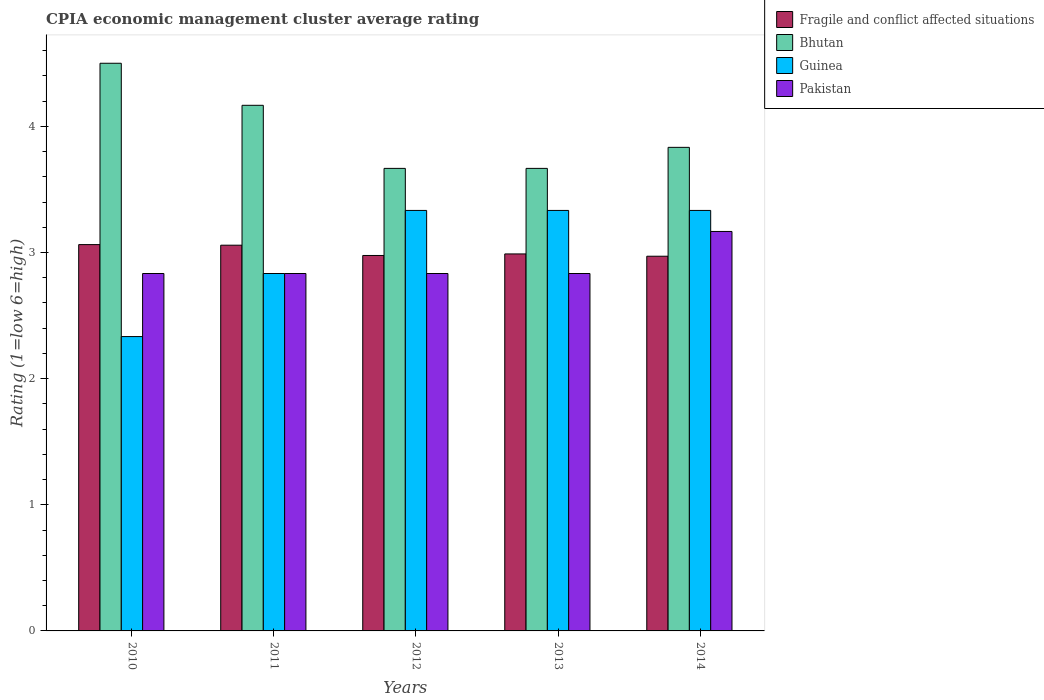How many different coloured bars are there?
Offer a terse response. 4. Are the number of bars per tick equal to the number of legend labels?
Offer a terse response. Yes. What is the CPIA rating in Guinea in 2012?
Your answer should be very brief. 3.33. Across all years, what is the maximum CPIA rating in Bhutan?
Your response must be concise. 4.5. Across all years, what is the minimum CPIA rating in Fragile and conflict affected situations?
Your response must be concise. 2.97. In which year was the CPIA rating in Guinea maximum?
Offer a terse response. 2012. In which year was the CPIA rating in Bhutan minimum?
Offer a very short reply. 2012. What is the total CPIA rating in Guinea in the graph?
Provide a succinct answer. 15.17. What is the difference between the CPIA rating in Fragile and conflict affected situations in 2011 and the CPIA rating in Bhutan in 2014?
Your response must be concise. -0.78. What is the average CPIA rating in Bhutan per year?
Provide a succinct answer. 3.97. In the year 2012, what is the difference between the CPIA rating in Bhutan and CPIA rating in Guinea?
Ensure brevity in your answer.  0.33. In how many years, is the CPIA rating in Pakistan greater than 2.6?
Give a very brief answer. 5. What is the ratio of the CPIA rating in Fragile and conflict affected situations in 2011 to that in 2013?
Your answer should be very brief. 1.02. What is the difference between the highest and the second highest CPIA rating in Bhutan?
Make the answer very short. 0.33. What is the difference between the highest and the lowest CPIA rating in Pakistan?
Your answer should be compact. 0.33. Is the sum of the CPIA rating in Bhutan in 2010 and 2011 greater than the maximum CPIA rating in Pakistan across all years?
Provide a short and direct response. Yes. What does the 3rd bar from the right in 2013 represents?
Keep it short and to the point. Bhutan. Is it the case that in every year, the sum of the CPIA rating in Fragile and conflict affected situations and CPIA rating in Pakistan is greater than the CPIA rating in Bhutan?
Provide a succinct answer. Yes. Does the graph contain any zero values?
Your answer should be compact. No. Where does the legend appear in the graph?
Keep it short and to the point. Top right. What is the title of the graph?
Offer a terse response. CPIA economic management cluster average rating. Does "Somalia" appear as one of the legend labels in the graph?
Keep it short and to the point. No. What is the label or title of the X-axis?
Provide a succinct answer. Years. What is the Rating (1=low 6=high) of Fragile and conflict affected situations in 2010?
Offer a very short reply. 3.06. What is the Rating (1=low 6=high) in Bhutan in 2010?
Offer a terse response. 4.5. What is the Rating (1=low 6=high) of Guinea in 2010?
Your answer should be very brief. 2.33. What is the Rating (1=low 6=high) in Pakistan in 2010?
Your response must be concise. 2.83. What is the Rating (1=low 6=high) in Fragile and conflict affected situations in 2011?
Ensure brevity in your answer.  3.06. What is the Rating (1=low 6=high) in Bhutan in 2011?
Offer a terse response. 4.17. What is the Rating (1=low 6=high) of Guinea in 2011?
Provide a succinct answer. 2.83. What is the Rating (1=low 6=high) of Pakistan in 2011?
Your response must be concise. 2.83. What is the Rating (1=low 6=high) of Fragile and conflict affected situations in 2012?
Ensure brevity in your answer.  2.98. What is the Rating (1=low 6=high) of Bhutan in 2012?
Keep it short and to the point. 3.67. What is the Rating (1=low 6=high) of Guinea in 2012?
Offer a very short reply. 3.33. What is the Rating (1=low 6=high) in Pakistan in 2012?
Offer a terse response. 2.83. What is the Rating (1=low 6=high) in Fragile and conflict affected situations in 2013?
Give a very brief answer. 2.99. What is the Rating (1=low 6=high) in Bhutan in 2013?
Ensure brevity in your answer.  3.67. What is the Rating (1=low 6=high) in Guinea in 2013?
Offer a terse response. 3.33. What is the Rating (1=low 6=high) in Pakistan in 2013?
Make the answer very short. 2.83. What is the Rating (1=low 6=high) of Fragile and conflict affected situations in 2014?
Your answer should be very brief. 2.97. What is the Rating (1=low 6=high) in Bhutan in 2014?
Give a very brief answer. 3.83. What is the Rating (1=low 6=high) of Guinea in 2014?
Provide a short and direct response. 3.33. What is the Rating (1=low 6=high) in Pakistan in 2014?
Provide a succinct answer. 3.17. Across all years, what is the maximum Rating (1=low 6=high) of Fragile and conflict affected situations?
Provide a short and direct response. 3.06. Across all years, what is the maximum Rating (1=low 6=high) in Guinea?
Ensure brevity in your answer.  3.33. Across all years, what is the maximum Rating (1=low 6=high) of Pakistan?
Make the answer very short. 3.17. Across all years, what is the minimum Rating (1=low 6=high) of Fragile and conflict affected situations?
Keep it short and to the point. 2.97. Across all years, what is the minimum Rating (1=low 6=high) in Bhutan?
Offer a terse response. 3.67. Across all years, what is the minimum Rating (1=low 6=high) in Guinea?
Your answer should be very brief. 2.33. Across all years, what is the minimum Rating (1=low 6=high) of Pakistan?
Ensure brevity in your answer.  2.83. What is the total Rating (1=low 6=high) in Fragile and conflict affected situations in the graph?
Keep it short and to the point. 15.06. What is the total Rating (1=low 6=high) of Bhutan in the graph?
Your answer should be compact. 19.83. What is the total Rating (1=low 6=high) of Guinea in the graph?
Give a very brief answer. 15.17. What is the total Rating (1=low 6=high) in Pakistan in the graph?
Your answer should be compact. 14.5. What is the difference between the Rating (1=low 6=high) in Fragile and conflict affected situations in 2010 and that in 2011?
Make the answer very short. 0. What is the difference between the Rating (1=low 6=high) of Bhutan in 2010 and that in 2011?
Offer a very short reply. 0.33. What is the difference between the Rating (1=low 6=high) of Pakistan in 2010 and that in 2011?
Offer a very short reply. 0. What is the difference between the Rating (1=low 6=high) in Fragile and conflict affected situations in 2010 and that in 2012?
Offer a terse response. 0.09. What is the difference between the Rating (1=low 6=high) in Guinea in 2010 and that in 2012?
Provide a short and direct response. -1. What is the difference between the Rating (1=low 6=high) in Fragile and conflict affected situations in 2010 and that in 2013?
Your response must be concise. 0.07. What is the difference between the Rating (1=low 6=high) of Guinea in 2010 and that in 2013?
Your answer should be compact. -1. What is the difference between the Rating (1=low 6=high) of Fragile and conflict affected situations in 2010 and that in 2014?
Offer a terse response. 0.09. What is the difference between the Rating (1=low 6=high) in Pakistan in 2010 and that in 2014?
Make the answer very short. -0.33. What is the difference between the Rating (1=low 6=high) of Fragile and conflict affected situations in 2011 and that in 2012?
Make the answer very short. 0.08. What is the difference between the Rating (1=low 6=high) of Bhutan in 2011 and that in 2012?
Keep it short and to the point. 0.5. What is the difference between the Rating (1=low 6=high) in Guinea in 2011 and that in 2012?
Your answer should be compact. -0.5. What is the difference between the Rating (1=low 6=high) of Fragile and conflict affected situations in 2011 and that in 2013?
Keep it short and to the point. 0.07. What is the difference between the Rating (1=low 6=high) in Guinea in 2011 and that in 2013?
Give a very brief answer. -0.5. What is the difference between the Rating (1=low 6=high) in Fragile and conflict affected situations in 2011 and that in 2014?
Your response must be concise. 0.09. What is the difference between the Rating (1=low 6=high) in Guinea in 2011 and that in 2014?
Ensure brevity in your answer.  -0.5. What is the difference between the Rating (1=low 6=high) in Pakistan in 2011 and that in 2014?
Your answer should be compact. -0.33. What is the difference between the Rating (1=low 6=high) of Fragile and conflict affected situations in 2012 and that in 2013?
Give a very brief answer. -0.01. What is the difference between the Rating (1=low 6=high) in Bhutan in 2012 and that in 2013?
Give a very brief answer. 0. What is the difference between the Rating (1=low 6=high) in Fragile and conflict affected situations in 2012 and that in 2014?
Offer a very short reply. 0.01. What is the difference between the Rating (1=low 6=high) in Bhutan in 2012 and that in 2014?
Your answer should be compact. -0.17. What is the difference between the Rating (1=low 6=high) in Guinea in 2012 and that in 2014?
Make the answer very short. 0. What is the difference between the Rating (1=low 6=high) of Pakistan in 2012 and that in 2014?
Your response must be concise. -0.33. What is the difference between the Rating (1=low 6=high) in Fragile and conflict affected situations in 2013 and that in 2014?
Ensure brevity in your answer.  0.02. What is the difference between the Rating (1=low 6=high) in Guinea in 2013 and that in 2014?
Give a very brief answer. 0. What is the difference between the Rating (1=low 6=high) in Pakistan in 2013 and that in 2014?
Your answer should be very brief. -0.33. What is the difference between the Rating (1=low 6=high) in Fragile and conflict affected situations in 2010 and the Rating (1=low 6=high) in Bhutan in 2011?
Offer a very short reply. -1.1. What is the difference between the Rating (1=low 6=high) in Fragile and conflict affected situations in 2010 and the Rating (1=low 6=high) in Guinea in 2011?
Provide a succinct answer. 0.23. What is the difference between the Rating (1=low 6=high) in Fragile and conflict affected situations in 2010 and the Rating (1=low 6=high) in Pakistan in 2011?
Offer a terse response. 0.23. What is the difference between the Rating (1=low 6=high) in Bhutan in 2010 and the Rating (1=low 6=high) in Guinea in 2011?
Offer a very short reply. 1.67. What is the difference between the Rating (1=low 6=high) of Guinea in 2010 and the Rating (1=low 6=high) of Pakistan in 2011?
Keep it short and to the point. -0.5. What is the difference between the Rating (1=low 6=high) of Fragile and conflict affected situations in 2010 and the Rating (1=low 6=high) of Bhutan in 2012?
Ensure brevity in your answer.  -0.6. What is the difference between the Rating (1=low 6=high) of Fragile and conflict affected situations in 2010 and the Rating (1=low 6=high) of Guinea in 2012?
Ensure brevity in your answer.  -0.27. What is the difference between the Rating (1=low 6=high) in Fragile and conflict affected situations in 2010 and the Rating (1=low 6=high) in Pakistan in 2012?
Your answer should be very brief. 0.23. What is the difference between the Rating (1=low 6=high) in Fragile and conflict affected situations in 2010 and the Rating (1=low 6=high) in Bhutan in 2013?
Ensure brevity in your answer.  -0.6. What is the difference between the Rating (1=low 6=high) in Fragile and conflict affected situations in 2010 and the Rating (1=low 6=high) in Guinea in 2013?
Provide a succinct answer. -0.27. What is the difference between the Rating (1=low 6=high) in Fragile and conflict affected situations in 2010 and the Rating (1=low 6=high) in Pakistan in 2013?
Make the answer very short. 0.23. What is the difference between the Rating (1=low 6=high) of Bhutan in 2010 and the Rating (1=low 6=high) of Guinea in 2013?
Your response must be concise. 1.17. What is the difference between the Rating (1=low 6=high) in Bhutan in 2010 and the Rating (1=low 6=high) in Pakistan in 2013?
Give a very brief answer. 1.67. What is the difference between the Rating (1=low 6=high) in Guinea in 2010 and the Rating (1=low 6=high) in Pakistan in 2013?
Make the answer very short. -0.5. What is the difference between the Rating (1=low 6=high) in Fragile and conflict affected situations in 2010 and the Rating (1=low 6=high) in Bhutan in 2014?
Offer a terse response. -0.77. What is the difference between the Rating (1=low 6=high) in Fragile and conflict affected situations in 2010 and the Rating (1=low 6=high) in Guinea in 2014?
Provide a succinct answer. -0.27. What is the difference between the Rating (1=low 6=high) of Fragile and conflict affected situations in 2010 and the Rating (1=low 6=high) of Pakistan in 2014?
Ensure brevity in your answer.  -0.1. What is the difference between the Rating (1=low 6=high) in Bhutan in 2010 and the Rating (1=low 6=high) in Guinea in 2014?
Keep it short and to the point. 1.17. What is the difference between the Rating (1=low 6=high) of Bhutan in 2010 and the Rating (1=low 6=high) of Pakistan in 2014?
Provide a short and direct response. 1.33. What is the difference between the Rating (1=low 6=high) in Guinea in 2010 and the Rating (1=low 6=high) in Pakistan in 2014?
Offer a terse response. -0.83. What is the difference between the Rating (1=low 6=high) of Fragile and conflict affected situations in 2011 and the Rating (1=low 6=high) of Bhutan in 2012?
Make the answer very short. -0.61. What is the difference between the Rating (1=low 6=high) in Fragile and conflict affected situations in 2011 and the Rating (1=low 6=high) in Guinea in 2012?
Keep it short and to the point. -0.28. What is the difference between the Rating (1=low 6=high) of Fragile and conflict affected situations in 2011 and the Rating (1=low 6=high) of Pakistan in 2012?
Your answer should be compact. 0.22. What is the difference between the Rating (1=low 6=high) of Bhutan in 2011 and the Rating (1=low 6=high) of Guinea in 2012?
Your answer should be very brief. 0.83. What is the difference between the Rating (1=low 6=high) in Bhutan in 2011 and the Rating (1=low 6=high) in Pakistan in 2012?
Ensure brevity in your answer.  1.33. What is the difference between the Rating (1=low 6=high) in Guinea in 2011 and the Rating (1=low 6=high) in Pakistan in 2012?
Offer a very short reply. 0. What is the difference between the Rating (1=low 6=high) of Fragile and conflict affected situations in 2011 and the Rating (1=low 6=high) of Bhutan in 2013?
Offer a very short reply. -0.61. What is the difference between the Rating (1=low 6=high) in Fragile and conflict affected situations in 2011 and the Rating (1=low 6=high) in Guinea in 2013?
Make the answer very short. -0.28. What is the difference between the Rating (1=low 6=high) in Fragile and conflict affected situations in 2011 and the Rating (1=low 6=high) in Pakistan in 2013?
Your answer should be compact. 0.22. What is the difference between the Rating (1=low 6=high) of Bhutan in 2011 and the Rating (1=low 6=high) of Guinea in 2013?
Ensure brevity in your answer.  0.83. What is the difference between the Rating (1=low 6=high) of Fragile and conflict affected situations in 2011 and the Rating (1=low 6=high) of Bhutan in 2014?
Ensure brevity in your answer.  -0.78. What is the difference between the Rating (1=low 6=high) in Fragile and conflict affected situations in 2011 and the Rating (1=low 6=high) in Guinea in 2014?
Provide a short and direct response. -0.28. What is the difference between the Rating (1=low 6=high) in Fragile and conflict affected situations in 2011 and the Rating (1=low 6=high) in Pakistan in 2014?
Give a very brief answer. -0.11. What is the difference between the Rating (1=low 6=high) in Bhutan in 2011 and the Rating (1=low 6=high) in Guinea in 2014?
Give a very brief answer. 0.83. What is the difference between the Rating (1=low 6=high) in Fragile and conflict affected situations in 2012 and the Rating (1=low 6=high) in Bhutan in 2013?
Make the answer very short. -0.69. What is the difference between the Rating (1=low 6=high) of Fragile and conflict affected situations in 2012 and the Rating (1=low 6=high) of Guinea in 2013?
Offer a terse response. -0.36. What is the difference between the Rating (1=low 6=high) in Fragile and conflict affected situations in 2012 and the Rating (1=low 6=high) in Pakistan in 2013?
Your answer should be very brief. 0.14. What is the difference between the Rating (1=low 6=high) in Bhutan in 2012 and the Rating (1=low 6=high) in Pakistan in 2013?
Your response must be concise. 0.83. What is the difference between the Rating (1=low 6=high) in Fragile and conflict affected situations in 2012 and the Rating (1=low 6=high) in Bhutan in 2014?
Offer a terse response. -0.86. What is the difference between the Rating (1=low 6=high) of Fragile and conflict affected situations in 2012 and the Rating (1=low 6=high) of Guinea in 2014?
Your answer should be compact. -0.36. What is the difference between the Rating (1=low 6=high) of Fragile and conflict affected situations in 2012 and the Rating (1=low 6=high) of Pakistan in 2014?
Make the answer very short. -0.19. What is the difference between the Rating (1=low 6=high) in Bhutan in 2012 and the Rating (1=low 6=high) in Guinea in 2014?
Offer a terse response. 0.33. What is the difference between the Rating (1=low 6=high) of Guinea in 2012 and the Rating (1=low 6=high) of Pakistan in 2014?
Keep it short and to the point. 0.17. What is the difference between the Rating (1=low 6=high) of Fragile and conflict affected situations in 2013 and the Rating (1=low 6=high) of Bhutan in 2014?
Your answer should be very brief. -0.84. What is the difference between the Rating (1=low 6=high) in Fragile and conflict affected situations in 2013 and the Rating (1=low 6=high) in Guinea in 2014?
Offer a terse response. -0.34. What is the difference between the Rating (1=low 6=high) of Fragile and conflict affected situations in 2013 and the Rating (1=low 6=high) of Pakistan in 2014?
Make the answer very short. -0.18. What is the difference between the Rating (1=low 6=high) of Bhutan in 2013 and the Rating (1=low 6=high) of Guinea in 2014?
Offer a terse response. 0.33. What is the difference between the Rating (1=low 6=high) in Guinea in 2013 and the Rating (1=low 6=high) in Pakistan in 2014?
Your response must be concise. 0.17. What is the average Rating (1=low 6=high) of Fragile and conflict affected situations per year?
Offer a very short reply. 3.01. What is the average Rating (1=low 6=high) in Bhutan per year?
Give a very brief answer. 3.97. What is the average Rating (1=low 6=high) in Guinea per year?
Your answer should be very brief. 3.03. What is the average Rating (1=low 6=high) in Pakistan per year?
Provide a succinct answer. 2.9. In the year 2010, what is the difference between the Rating (1=low 6=high) in Fragile and conflict affected situations and Rating (1=low 6=high) in Bhutan?
Offer a terse response. -1.44. In the year 2010, what is the difference between the Rating (1=low 6=high) in Fragile and conflict affected situations and Rating (1=low 6=high) in Guinea?
Offer a terse response. 0.73. In the year 2010, what is the difference between the Rating (1=low 6=high) in Fragile and conflict affected situations and Rating (1=low 6=high) in Pakistan?
Offer a terse response. 0.23. In the year 2010, what is the difference between the Rating (1=low 6=high) in Bhutan and Rating (1=low 6=high) in Guinea?
Provide a succinct answer. 2.17. In the year 2010, what is the difference between the Rating (1=low 6=high) of Guinea and Rating (1=low 6=high) of Pakistan?
Your response must be concise. -0.5. In the year 2011, what is the difference between the Rating (1=low 6=high) in Fragile and conflict affected situations and Rating (1=low 6=high) in Bhutan?
Your answer should be very brief. -1.11. In the year 2011, what is the difference between the Rating (1=low 6=high) of Fragile and conflict affected situations and Rating (1=low 6=high) of Guinea?
Provide a short and direct response. 0.22. In the year 2011, what is the difference between the Rating (1=low 6=high) in Fragile and conflict affected situations and Rating (1=low 6=high) in Pakistan?
Keep it short and to the point. 0.22. In the year 2011, what is the difference between the Rating (1=low 6=high) of Bhutan and Rating (1=low 6=high) of Pakistan?
Make the answer very short. 1.33. In the year 2012, what is the difference between the Rating (1=low 6=high) in Fragile and conflict affected situations and Rating (1=low 6=high) in Bhutan?
Make the answer very short. -0.69. In the year 2012, what is the difference between the Rating (1=low 6=high) of Fragile and conflict affected situations and Rating (1=low 6=high) of Guinea?
Your answer should be very brief. -0.36. In the year 2012, what is the difference between the Rating (1=low 6=high) in Fragile and conflict affected situations and Rating (1=low 6=high) in Pakistan?
Ensure brevity in your answer.  0.14. In the year 2012, what is the difference between the Rating (1=low 6=high) in Bhutan and Rating (1=low 6=high) in Guinea?
Ensure brevity in your answer.  0.33. In the year 2013, what is the difference between the Rating (1=low 6=high) of Fragile and conflict affected situations and Rating (1=low 6=high) of Bhutan?
Your answer should be very brief. -0.68. In the year 2013, what is the difference between the Rating (1=low 6=high) in Fragile and conflict affected situations and Rating (1=low 6=high) in Guinea?
Provide a short and direct response. -0.34. In the year 2013, what is the difference between the Rating (1=low 6=high) of Fragile and conflict affected situations and Rating (1=low 6=high) of Pakistan?
Your response must be concise. 0.16. In the year 2013, what is the difference between the Rating (1=low 6=high) in Guinea and Rating (1=low 6=high) in Pakistan?
Ensure brevity in your answer.  0.5. In the year 2014, what is the difference between the Rating (1=low 6=high) in Fragile and conflict affected situations and Rating (1=low 6=high) in Bhutan?
Provide a short and direct response. -0.86. In the year 2014, what is the difference between the Rating (1=low 6=high) of Fragile and conflict affected situations and Rating (1=low 6=high) of Guinea?
Offer a terse response. -0.36. In the year 2014, what is the difference between the Rating (1=low 6=high) of Fragile and conflict affected situations and Rating (1=low 6=high) of Pakistan?
Your answer should be very brief. -0.2. In the year 2014, what is the difference between the Rating (1=low 6=high) of Bhutan and Rating (1=low 6=high) of Guinea?
Your answer should be compact. 0.5. In the year 2014, what is the difference between the Rating (1=low 6=high) in Guinea and Rating (1=low 6=high) in Pakistan?
Your answer should be very brief. 0.17. What is the ratio of the Rating (1=low 6=high) in Bhutan in 2010 to that in 2011?
Offer a very short reply. 1.08. What is the ratio of the Rating (1=low 6=high) in Guinea in 2010 to that in 2011?
Keep it short and to the point. 0.82. What is the ratio of the Rating (1=low 6=high) of Pakistan in 2010 to that in 2011?
Your response must be concise. 1. What is the ratio of the Rating (1=low 6=high) of Bhutan in 2010 to that in 2012?
Keep it short and to the point. 1.23. What is the ratio of the Rating (1=low 6=high) of Guinea in 2010 to that in 2012?
Give a very brief answer. 0.7. What is the ratio of the Rating (1=low 6=high) in Pakistan in 2010 to that in 2012?
Give a very brief answer. 1. What is the ratio of the Rating (1=low 6=high) of Fragile and conflict affected situations in 2010 to that in 2013?
Your answer should be very brief. 1.02. What is the ratio of the Rating (1=low 6=high) in Bhutan in 2010 to that in 2013?
Provide a succinct answer. 1.23. What is the ratio of the Rating (1=low 6=high) of Guinea in 2010 to that in 2013?
Ensure brevity in your answer.  0.7. What is the ratio of the Rating (1=low 6=high) in Fragile and conflict affected situations in 2010 to that in 2014?
Give a very brief answer. 1.03. What is the ratio of the Rating (1=low 6=high) in Bhutan in 2010 to that in 2014?
Offer a terse response. 1.17. What is the ratio of the Rating (1=low 6=high) of Pakistan in 2010 to that in 2014?
Offer a very short reply. 0.89. What is the ratio of the Rating (1=low 6=high) in Fragile and conflict affected situations in 2011 to that in 2012?
Offer a terse response. 1.03. What is the ratio of the Rating (1=low 6=high) of Bhutan in 2011 to that in 2012?
Keep it short and to the point. 1.14. What is the ratio of the Rating (1=low 6=high) of Pakistan in 2011 to that in 2012?
Keep it short and to the point. 1. What is the ratio of the Rating (1=low 6=high) in Fragile and conflict affected situations in 2011 to that in 2013?
Make the answer very short. 1.02. What is the ratio of the Rating (1=low 6=high) in Bhutan in 2011 to that in 2013?
Make the answer very short. 1.14. What is the ratio of the Rating (1=low 6=high) of Pakistan in 2011 to that in 2013?
Provide a succinct answer. 1. What is the ratio of the Rating (1=low 6=high) in Fragile and conflict affected situations in 2011 to that in 2014?
Your answer should be very brief. 1.03. What is the ratio of the Rating (1=low 6=high) in Bhutan in 2011 to that in 2014?
Ensure brevity in your answer.  1.09. What is the ratio of the Rating (1=low 6=high) of Guinea in 2011 to that in 2014?
Make the answer very short. 0.85. What is the ratio of the Rating (1=low 6=high) in Pakistan in 2011 to that in 2014?
Provide a short and direct response. 0.89. What is the ratio of the Rating (1=low 6=high) in Fragile and conflict affected situations in 2012 to that in 2013?
Make the answer very short. 1. What is the ratio of the Rating (1=low 6=high) in Bhutan in 2012 to that in 2013?
Offer a terse response. 1. What is the ratio of the Rating (1=low 6=high) in Pakistan in 2012 to that in 2013?
Provide a short and direct response. 1. What is the ratio of the Rating (1=low 6=high) in Fragile and conflict affected situations in 2012 to that in 2014?
Provide a short and direct response. 1. What is the ratio of the Rating (1=low 6=high) in Bhutan in 2012 to that in 2014?
Provide a short and direct response. 0.96. What is the ratio of the Rating (1=low 6=high) of Pakistan in 2012 to that in 2014?
Keep it short and to the point. 0.89. What is the ratio of the Rating (1=low 6=high) of Fragile and conflict affected situations in 2013 to that in 2014?
Your response must be concise. 1.01. What is the ratio of the Rating (1=low 6=high) in Bhutan in 2013 to that in 2014?
Your answer should be compact. 0.96. What is the ratio of the Rating (1=low 6=high) in Pakistan in 2013 to that in 2014?
Give a very brief answer. 0.89. What is the difference between the highest and the second highest Rating (1=low 6=high) in Fragile and conflict affected situations?
Your response must be concise. 0. What is the difference between the highest and the second highest Rating (1=low 6=high) in Pakistan?
Provide a succinct answer. 0.33. What is the difference between the highest and the lowest Rating (1=low 6=high) of Fragile and conflict affected situations?
Provide a short and direct response. 0.09. What is the difference between the highest and the lowest Rating (1=low 6=high) of Pakistan?
Offer a very short reply. 0.33. 